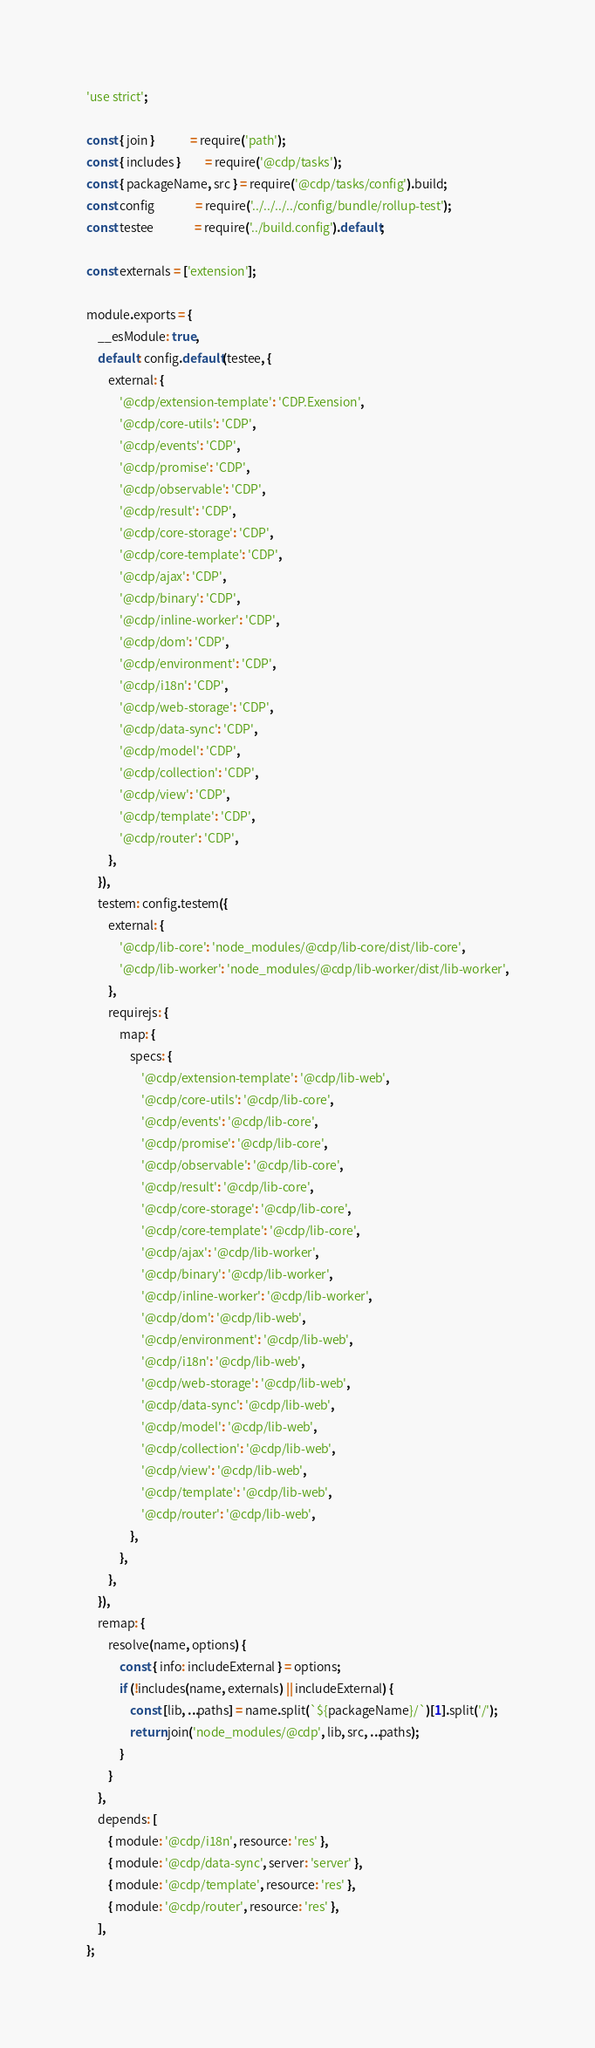<code> <loc_0><loc_0><loc_500><loc_500><_JavaScript_>'use strict';

const { join }             = require('path');
const { includes }         = require('@cdp/tasks');
const { packageName, src } = require('@cdp/tasks/config').build;
const config               = require('../../../../config/bundle/rollup-test');
const testee               = require('../build.config').default;

const externals = ['extension'];

module.exports = {
    __esModule: true,
    default: config.default(testee, {
        external: {
            '@cdp/extension-template': 'CDP.Exension',
            '@cdp/core-utils': 'CDP',
            '@cdp/events': 'CDP',
            '@cdp/promise': 'CDP',
            '@cdp/observable': 'CDP',
            '@cdp/result': 'CDP',
            '@cdp/core-storage': 'CDP',
            '@cdp/core-template': 'CDP',
            '@cdp/ajax': 'CDP',
            '@cdp/binary': 'CDP',
            '@cdp/inline-worker': 'CDP',
            '@cdp/dom': 'CDP',
            '@cdp/environment': 'CDP',
            '@cdp/i18n': 'CDP',
            '@cdp/web-storage': 'CDP',
            '@cdp/data-sync': 'CDP',
            '@cdp/model': 'CDP',
            '@cdp/collection': 'CDP',
            '@cdp/view': 'CDP',
            '@cdp/template': 'CDP',
            '@cdp/router': 'CDP',
        },
    }),
    testem: config.testem({
        external: {
            '@cdp/lib-core': 'node_modules/@cdp/lib-core/dist/lib-core',
            '@cdp/lib-worker': 'node_modules/@cdp/lib-worker/dist/lib-worker',
        },
        requirejs: {
            map: {
                specs: {
                    '@cdp/extension-template': '@cdp/lib-web',
                    '@cdp/core-utils': '@cdp/lib-core',
                    '@cdp/events': '@cdp/lib-core',
                    '@cdp/promise': '@cdp/lib-core',
                    '@cdp/observable': '@cdp/lib-core',
                    '@cdp/result': '@cdp/lib-core',
                    '@cdp/core-storage': '@cdp/lib-core',
                    '@cdp/core-template': '@cdp/lib-core',
                    '@cdp/ajax': '@cdp/lib-worker',
                    '@cdp/binary': '@cdp/lib-worker',
                    '@cdp/inline-worker': '@cdp/lib-worker',
                    '@cdp/dom': '@cdp/lib-web',
                    '@cdp/environment': '@cdp/lib-web',
                    '@cdp/i18n': '@cdp/lib-web',
                    '@cdp/web-storage': '@cdp/lib-web',
                    '@cdp/data-sync': '@cdp/lib-web',
                    '@cdp/model': '@cdp/lib-web',
                    '@cdp/collection': '@cdp/lib-web',
                    '@cdp/view': '@cdp/lib-web',
                    '@cdp/template': '@cdp/lib-web',
                    '@cdp/router': '@cdp/lib-web',
                },
            },
        },
    }),
    remap: {
        resolve(name, options) {
            const { info: includeExternal } = options;
            if (!includes(name, externals) || includeExternal) {
                const [lib, ...paths] = name.split(`${packageName}/`)[1].split('/');
                return join('node_modules/@cdp', lib, src, ...paths);
            }
        }
    },
    depends: [
        { module: '@cdp/i18n', resource: 'res' },
        { module: '@cdp/data-sync', server: 'server' },
        { module: '@cdp/template', resource: 'res' },
        { module: '@cdp/router', resource: 'res' },
    ],
};
</code> 